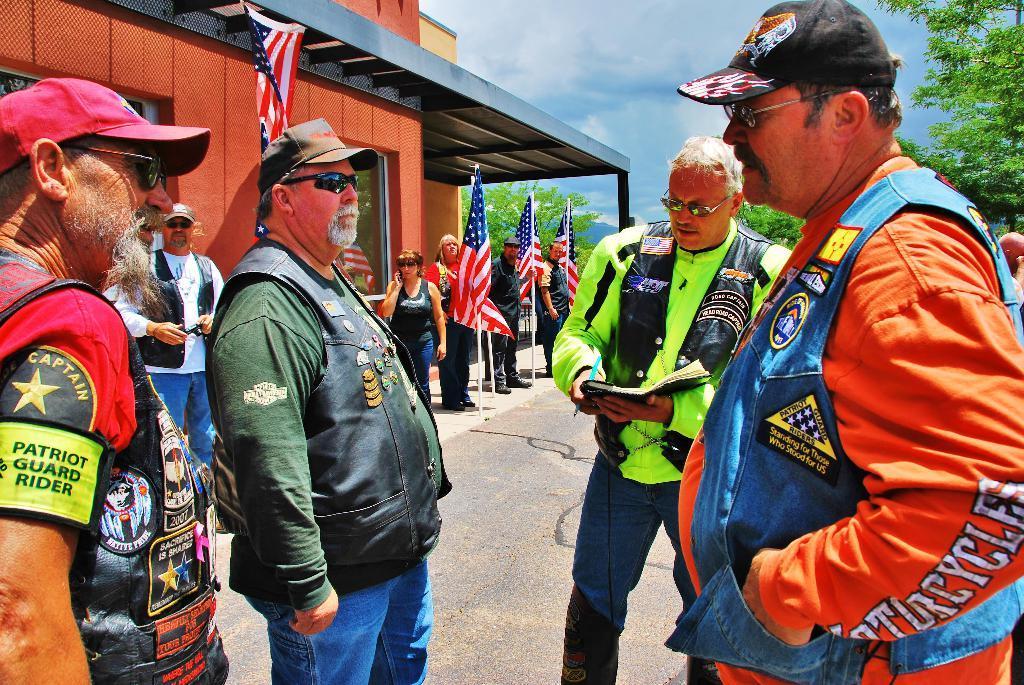Could you give a brief overview of what you see in this image? In the foreground of this image, there are four men standing wearing jackets and a man is holding a book. In the background, there are few flags and people standing and walking on the path. Behind them, there is a building. In the background, there are trees and the sky. 